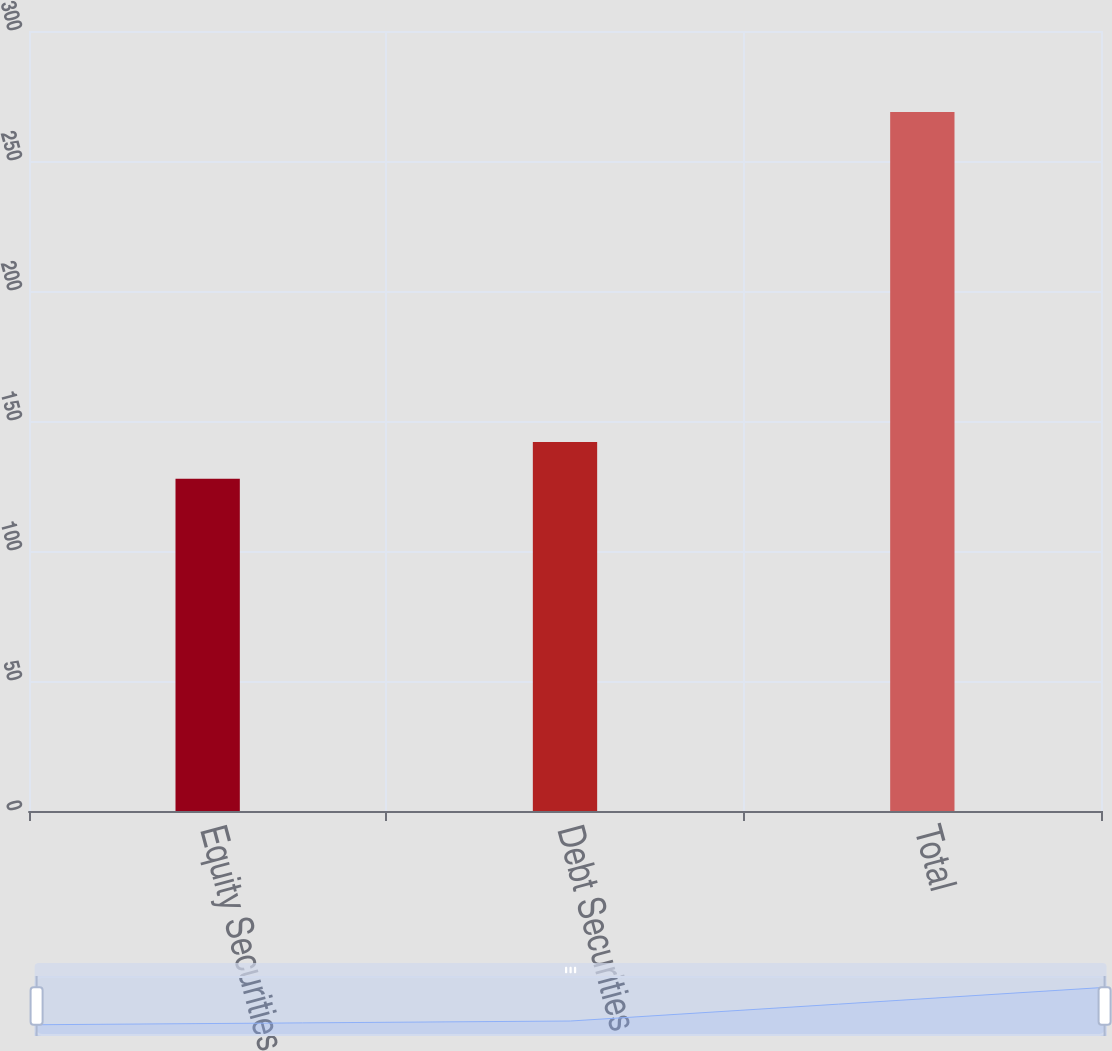Convert chart. <chart><loc_0><loc_0><loc_500><loc_500><bar_chart><fcel>Equity Securities<fcel>Debt Securities<fcel>Total<nl><fcel>127.8<fcel>141.9<fcel>268.8<nl></chart> 